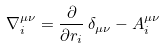Convert formula to latex. <formula><loc_0><loc_0><loc_500><loc_500>\nabla ^ { \mu \nu } _ { i } = \frac { \partial } { \partial r _ { i } } \, \delta _ { \mu \nu } - A _ { i } ^ { \mu \nu }</formula> 